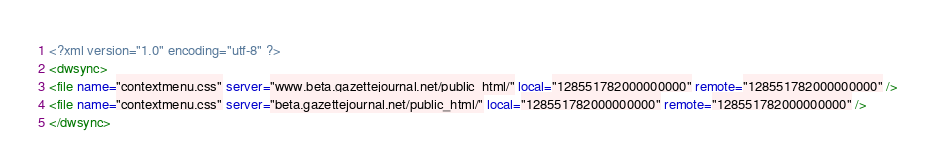<code> <loc_0><loc_0><loc_500><loc_500><_XML_><?xml version="1.0" encoding="utf-8" ?>
<dwsync>
<file name="contextmenu.css" server="www.beta.gazettejournal.net/public_html/" local="128551782000000000" remote="128551782000000000" />
<file name="contextmenu.css" server="beta.gazettejournal.net/public_html/" local="128551782000000000" remote="128551782000000000" />
</dwsync></code> 